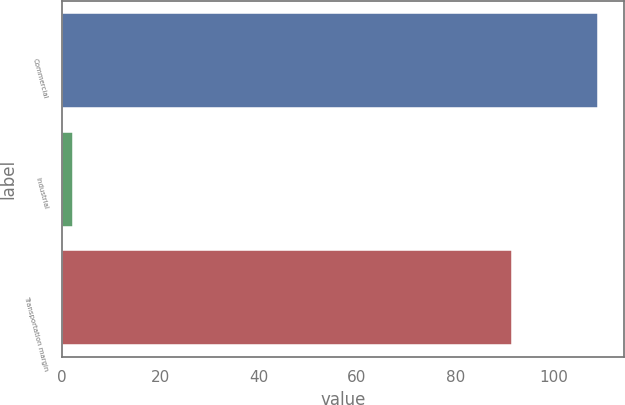Convert chart. <chart><loc_0><loc_0><loc_500><loc_500><bar_chart><fcel>Commercial<fcel>Industrial<fcel>Transportation margin<nl><fcel>108.9<fcel>2.2<fcel>91.5<nl></chart> 